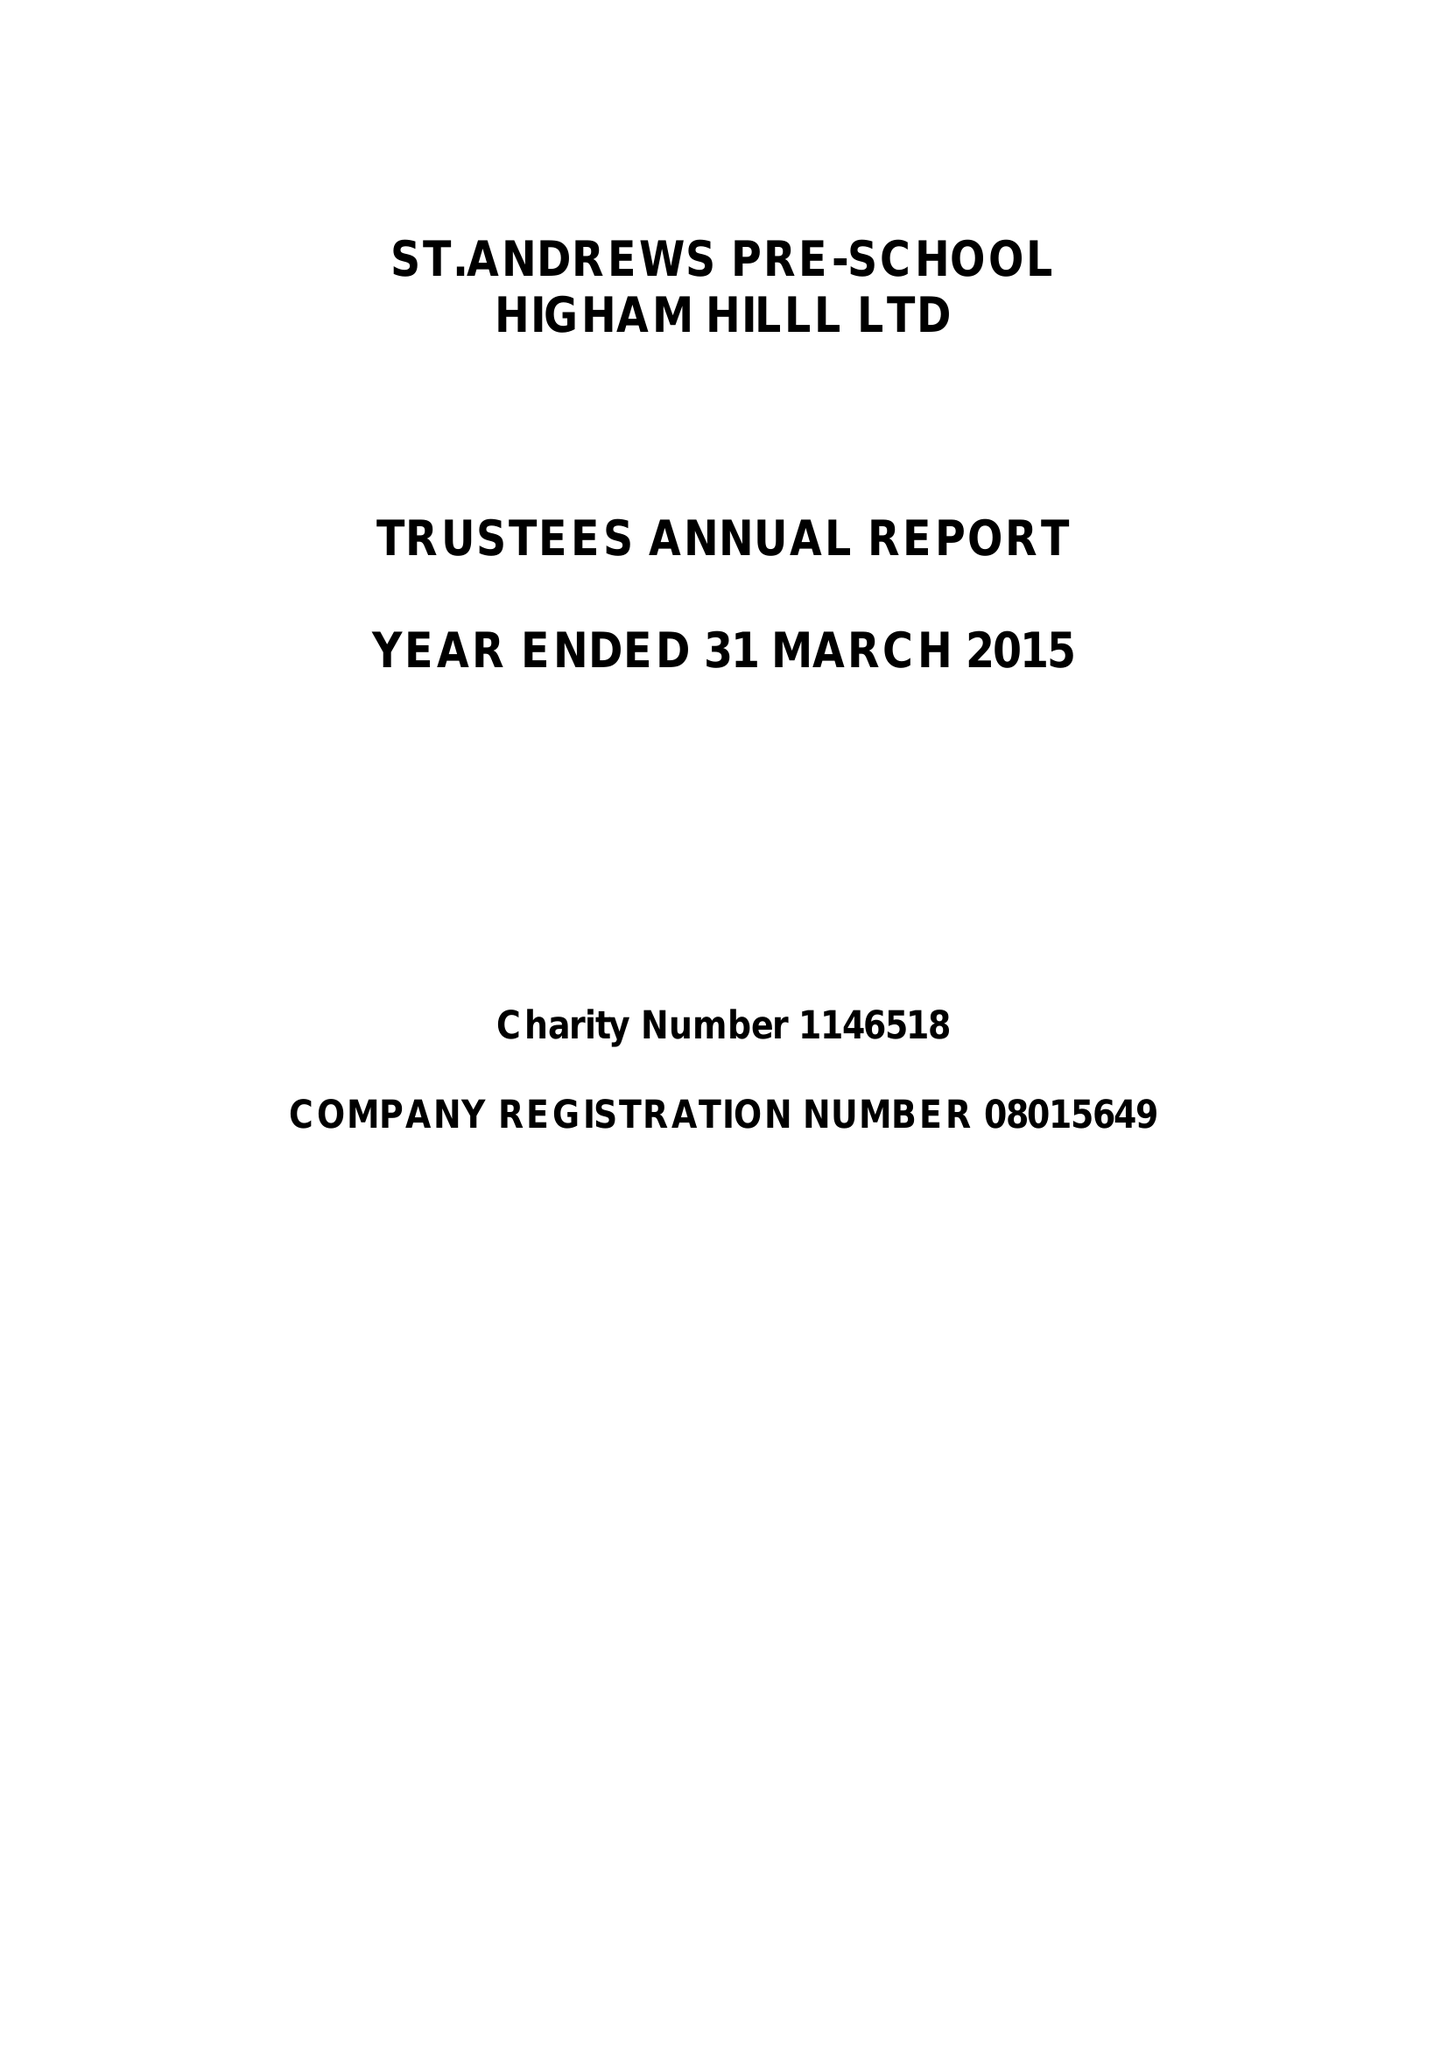What is the value for the spending_annually_in_british_pounds?
Answer the question using a single word or phrase. 102129.00 